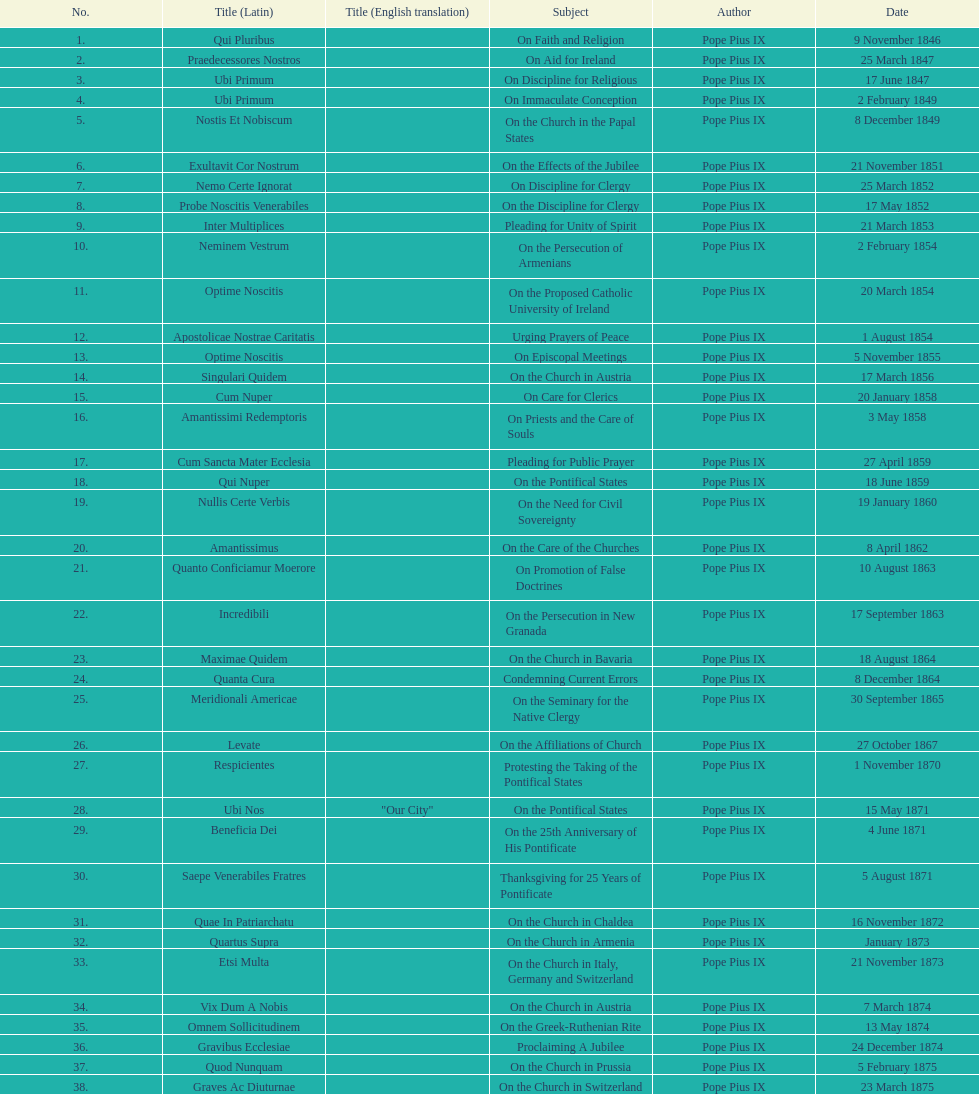Latin title of the encyclical before the encyclical with the subject "on the church in bavaria" Incredibili. 